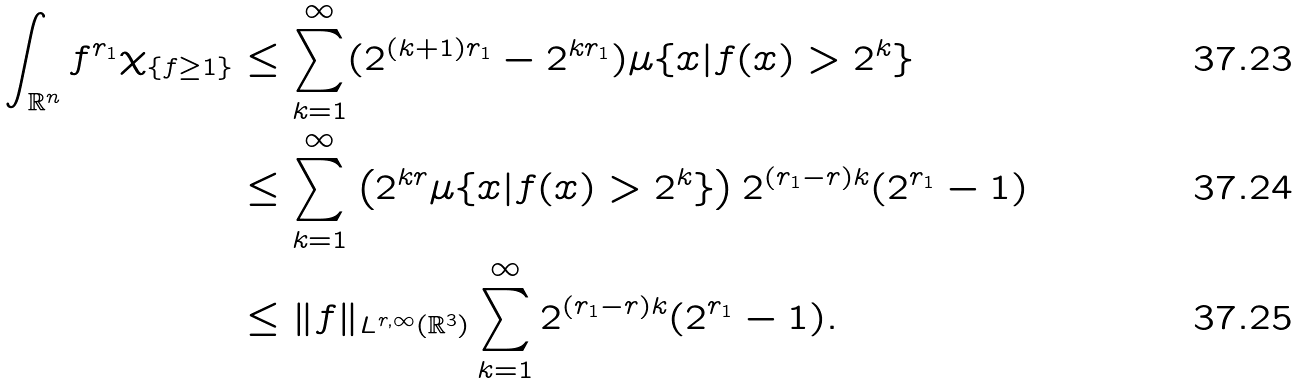<formula> <loc_0><loc_0><loc_500><loc_500>\int _ { \mathbb { R } ^ { n } } f ^ { r _ { 1 } } \chi _ { \{ f \geq 1 \} } & \leq \sum _ { k = 1 } ^ { \infty } ( 2 ^ { ( k + 1 ) r _ { 1 } } - 2 ^ { k r _ { 1 } } ) \mu \{ x | f ( x ) > 2 ^ { k } \} \\ & \leq \sum _ { k = 1 } ^ { \infty } \left ( 2 ^ { k r } \mu \{ x | f ( x ) > 2 ^ { k } \} \right ) 2 ^ { ( r _ { 1 } - r ) k } ( 2 ^ { r _ { 1 } } - 1 ) \\ & \leq \| f \| _ { L ^ { r , \infty } ( \mathbb { R } ^ { 3 } ) } \sum _ { k = 1 } ^ { \infty } 2 ^ { ( r _ { 1 } - r ) k } ( 2 ^ { r _ { 1 } } - 1 ) .</formula> 